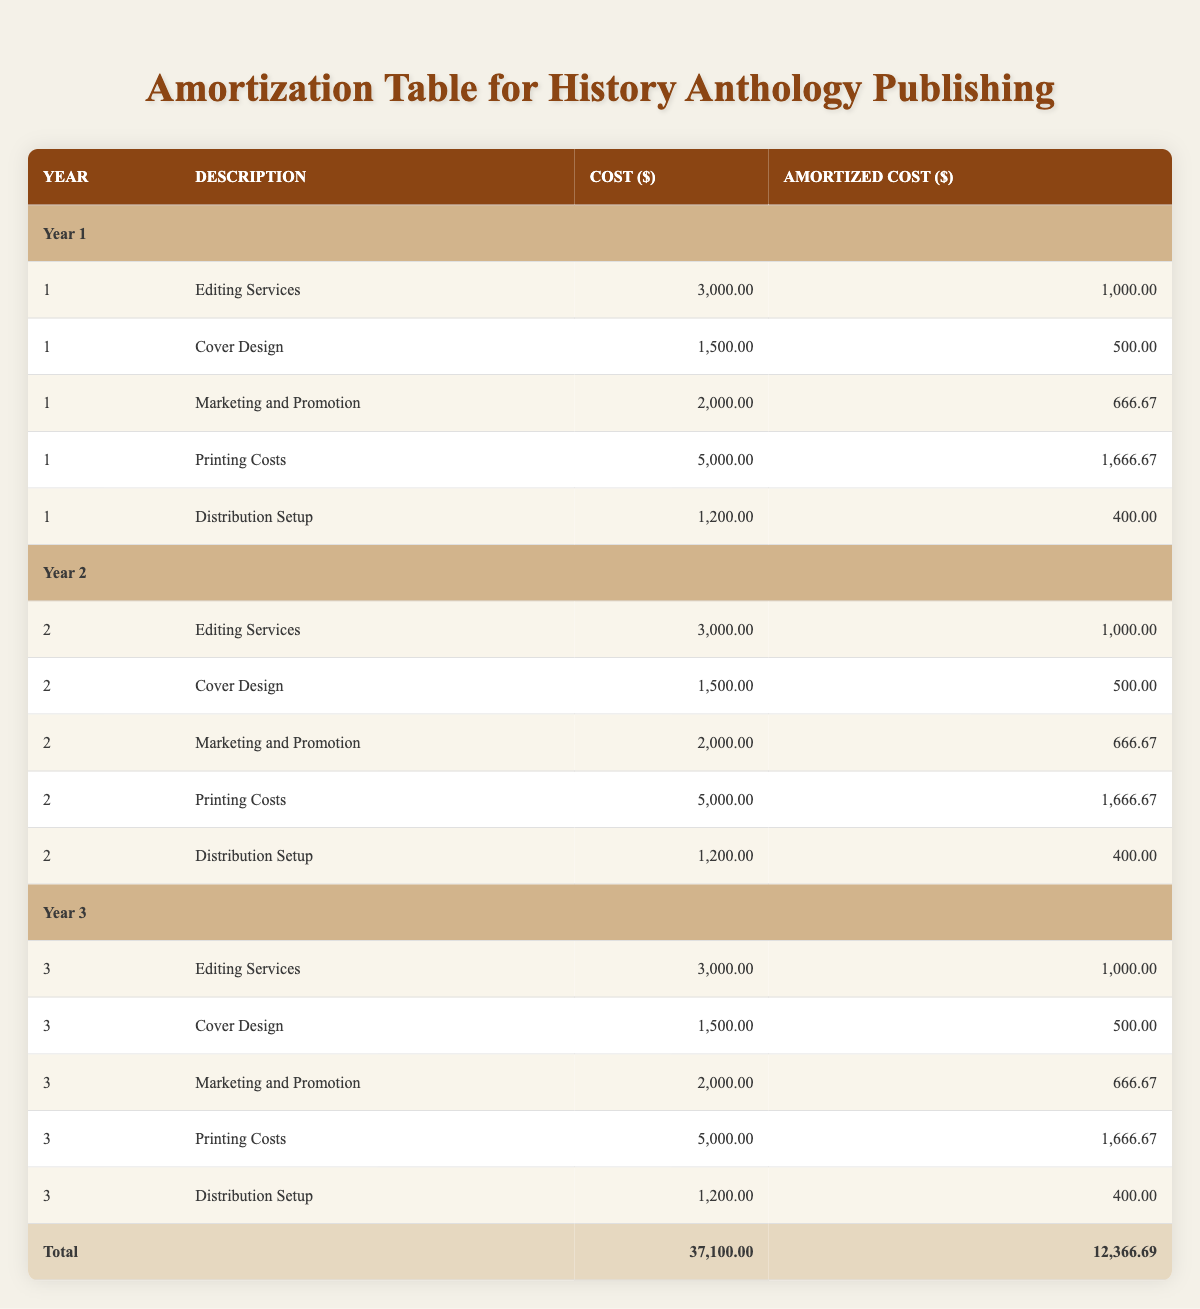What is the total cost associated with publishing in Year 1? To find the total cost for Year 1, I add the costs of all the entries under Year 1: 3000 + 1500 + 2000 + 5000 + 1200 = 13700.
Answer: 13700 What is the amortized cost for Marketing and Promotion in Year 2? According to the table, the amortized cost for Marketing and Promotion in Year 2 is directly shown as 666.67.
Answer: 666.67 Is the cost for Printing Costs the same every year? The cost for Printing Costs each year is 5000, which remains consistent across all three years, indicating that it is indeed the same every year.
Answer: Yes What is the average amortized cost for Distribution Setup over the three years? The amortized cost for Distribution Setup across the three years is 400 (Year 1) + 400 (Year 2) + 400 (Year 3) = 1200. The average is 1200/3 = 400.
Answer: 400 What is the total amortized cost for all categories in Year 3? To find the total amortized cost in Year 3, I sum the amortized costs for Year 3: 1000 + 500 + 666.67 + 1666.67 + 400 = 3334.34.
Answer: 3334.34 What is the highest single cost category in Year 2? Comparing the cost categories for Year 2, Editing Services (3000) is the highest cost category, exceeding all others listed that year.
Answer: Editing Services What is the total cost for all three years combined? To calculate the total cost for all three years, I sum the total costs from Year 1 (13700), Year 2 (13700), and Year 3 (13700): 13700 + 13700 + 13700 = 41100.
Answer: 41100 Was the Marketing and Promotion cost higher in Year 1 than in Year 3? The Marketing and Promotion cost is 2000 in Year 1 and 2000 in Year 3, thus they are equal, so it is not higher in Year 1.
Answer: No What is the total amortized cost for all years combined? The total amortized cost for all three years is calculated by summing all amortized costs: 1000 + 500 + 666.67 + 1666.67 + 400 + 1000 + 500 + 666.67 + 1666.67 + 400 + 1000 + 500 + 666.67 + 1666.67 + 400 = 3700 + 3700 + 3700 = 11000.
Answer: 11000 